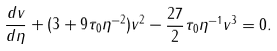Convert formula to latex. <formula><loc_0><loc_0><loc_500><loc_500>\frac { d v } { d \eta } + ( 3 + 9 \tau _ { 0 } \eta ^ { - 2 } ) v ^ { 2 } - \frac { 2 7 } 2 \tau _ { 0 } \eta ^ { - 1 } v ^ { 3 } = 0 .</formula> 